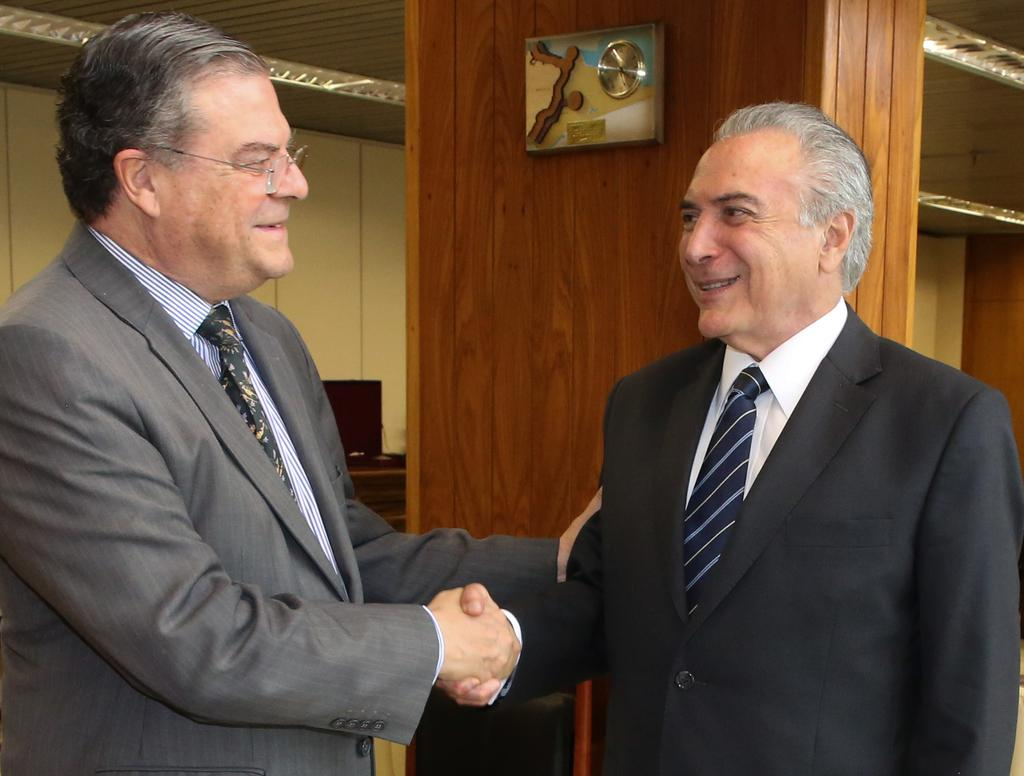How many persons are in the image? There are persons standing in the image. Where are the persons standing? The persons are standing on the floor. What can be seen in the background of the image? There is a system, a wall, and lights visible in the background of the image. What type of instrument is being played by the persons in the image? There is no instrument present in the image; the persons are simply standing. Can you recite a verse from the image? There is no verse present in the image; it is a scene with persons standing and a background with a system, wall, and lights. 